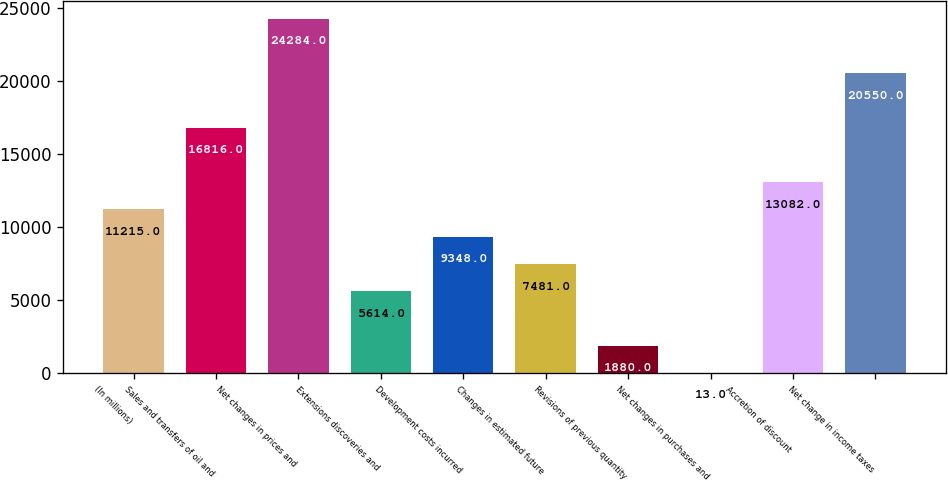Convert chart. <chart><loc_0><loc_0><loc_500><loc_500><bar_chart><fcel>(In millions)<fcel>Sales and transfers of oil and<fcel>Net changes in prices and<fcel>Extensions discoveries and<fcel>Development costs incurred<fcel>Changes in estimated future<fcel>Revisions of previous quantity<fcel>Net changes in purchases and<fcel>Accretion of discount<fcel>Net change in income taxes<nl><fcel>11215<fcel>16816<fcel>24284<fcel>5614<fcel>9348<fcel>7481<fcel>1880<fcel>13<fcel>13082<fcel>20550<nl></chart> 